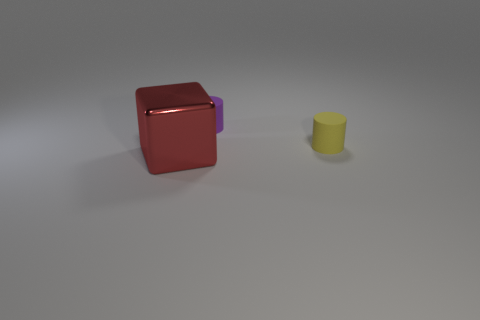Add 1 yellow rubber cylinders. How many objects exist? 4 Subtract all blocks. How many objects are left? 2 Subtract 1 purple cylinders. How many objects are left? 2 Subtract all cyan matte blocks. Subtract all yellow rubber cylinders. How many objects are left? 2 Add 2 small purple rubber cylinders. How many small purple rubber cylinders are left? 3 Add 2 red cubes. How many red cubes exist? 3 